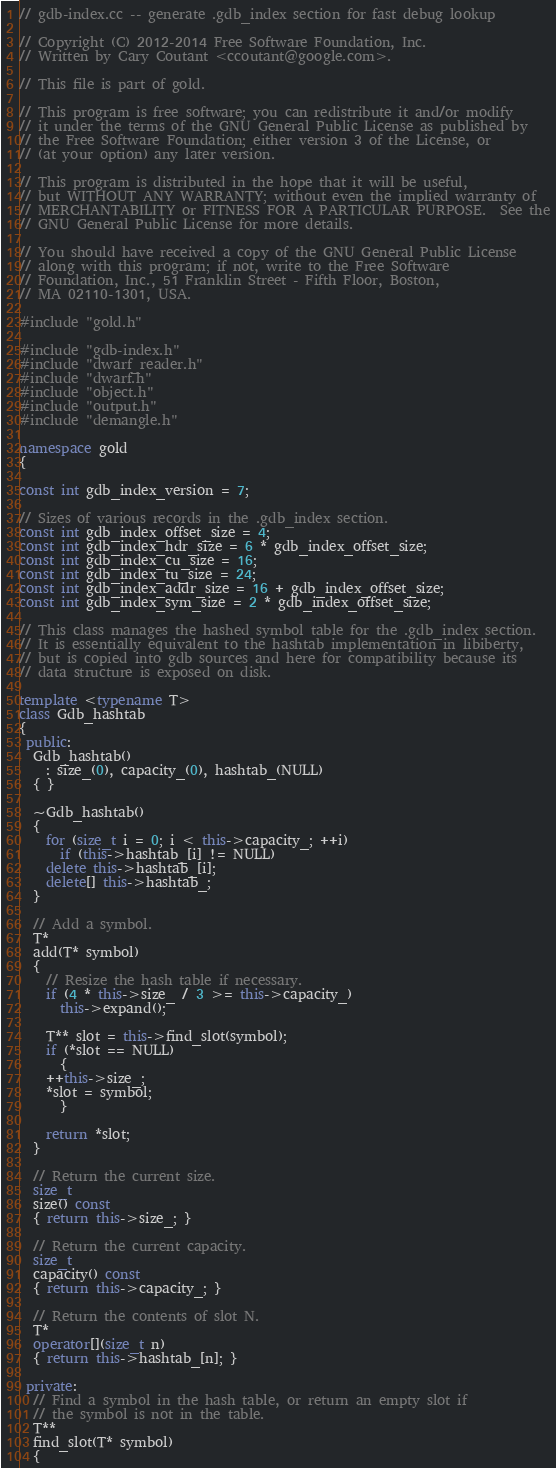<code> <loc_0><loc_0><loc_500><loc_500><_C++_>// gdb-index.cc -- generate .gdb_index section for fast debug lookup

// Copyright (C) 2012-2014 Free Software Foundation, Inc.
// Written by Cary Coutant <ccoutant@google.com>.

// This file is part of gold.

// This program is free software; you can redistribute it and/or modify
// it under the terms of the GNU General Public License as published by
// the Free Software Foundation; either version 3 of the License, or
// (at your option) any later version.

// This program is distributed in the hope that it will be useful,
// but WITHOUT ANY WARRANTY; without even the implied warranty of
// MERCHANTABILITY or FITNESS FOR A PARTICULAR PURPOSE.  See the
// GNU General Public License for more details.

// You should have received a copy of the GNU General Public License
// along with this program; if not, write to the Free Software
// Foundation, Inc., 51 Franklin Street - Fifth Floor, Boston,
// MA 02110-1301, USA.

#include "gold.h"

#include "gdb-index.h"
#include "dwarf_reader.h"
#include "dwarf.h"
#include "object.h"
#include "output.h"
#include "demangle.h"

namespace gold
{

const int gdb_index_version = 7;

// Sizes of various records in the .gdb_index section.
const int gdb_index_offset_size = 4;
const int gdb_index_hdr_size = 6 * gdb_index_offset_size;
const int gdb_index_cu_size = 16;
const int gdb_index_tu_size = 24;
const int gdb_index_addr_size = 16 + gdb_index_offset_size;
const int gdb_index_sym_size = 2 * gdb_index_offset_size;

// This class manages the hashed symbol table for the .gdb_index section.
// It is essentially equivalent to the hashtab implementation in libiberty,
// but is copied into gdb sources and here for compatibility because its
// data structure is exposed on disk.

template <typename T>
class Gdb_hashtab
{
 public:
  Gdb_hashtab()
    : size_(0), capacity_(0), hashtab_(NULL)
  { }

  ~Gdb_hashtab()
  {
    for (size_t i = 0; i < this->capacity_; ++i)
      if (this->hashtab_[i] != NULL)
	delete this->hashtab_[i];
    delete[] this->hashtab_;
  }

  // Add a symbol.
  T*
  add(T* symbol)
  {
    // Resize the hash table if necessary.
    if (4 * this->size_ / 3 >= this->capacity_)
      this->expand();

    T** slot = this->find_slot(symbol);
    if (*slot == NULL)
      {
	++this->size_;
	*slot = symbol;
      }

    return *slot;
  }

  // Return the current size.
  size_t
  size() const
  { return this->size_; }

  // Return the current capacity.
  size_t
  capacity() const
  { return this->capacity_; }

  // Return the contents of slot N.
  T*
  operator[](size_t n)
  { return this->hashtab_[n]; }

 private:
  // Find a symbol in the hash table, or return an empty slot if
  // the symbol is not in the table.
  T**
  find_slot(T* symbol)
  {</code> 